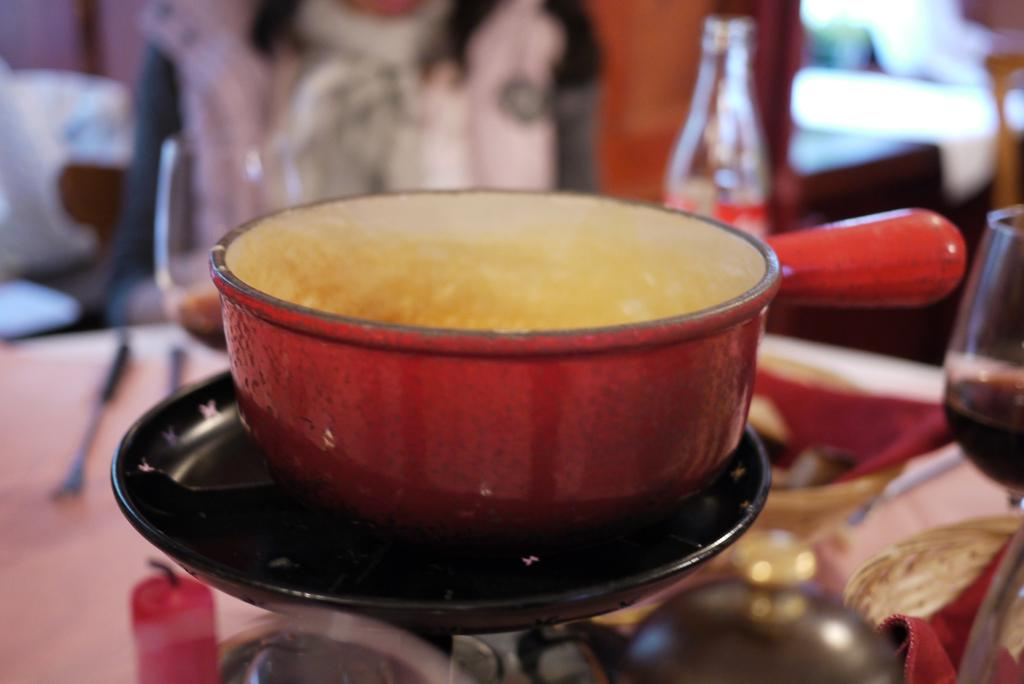What piece of furniture is present in the image? There is a table in the image. What items are placed on the table? There are glasses, bottles, a pan, and a candle on the table. Who is present in the image? There is a person sitting beside the table. What is the condition of the background in the image? The background of the image is blurry. What invention is being demonstrated by the person in the image? There is no invention being demonstrated in the image; it simply shows a person sitting beside a table with various items on it. What company is responsible for the design of the pan in the image? There is no information about the company responsible for the design of the pan in the image. 